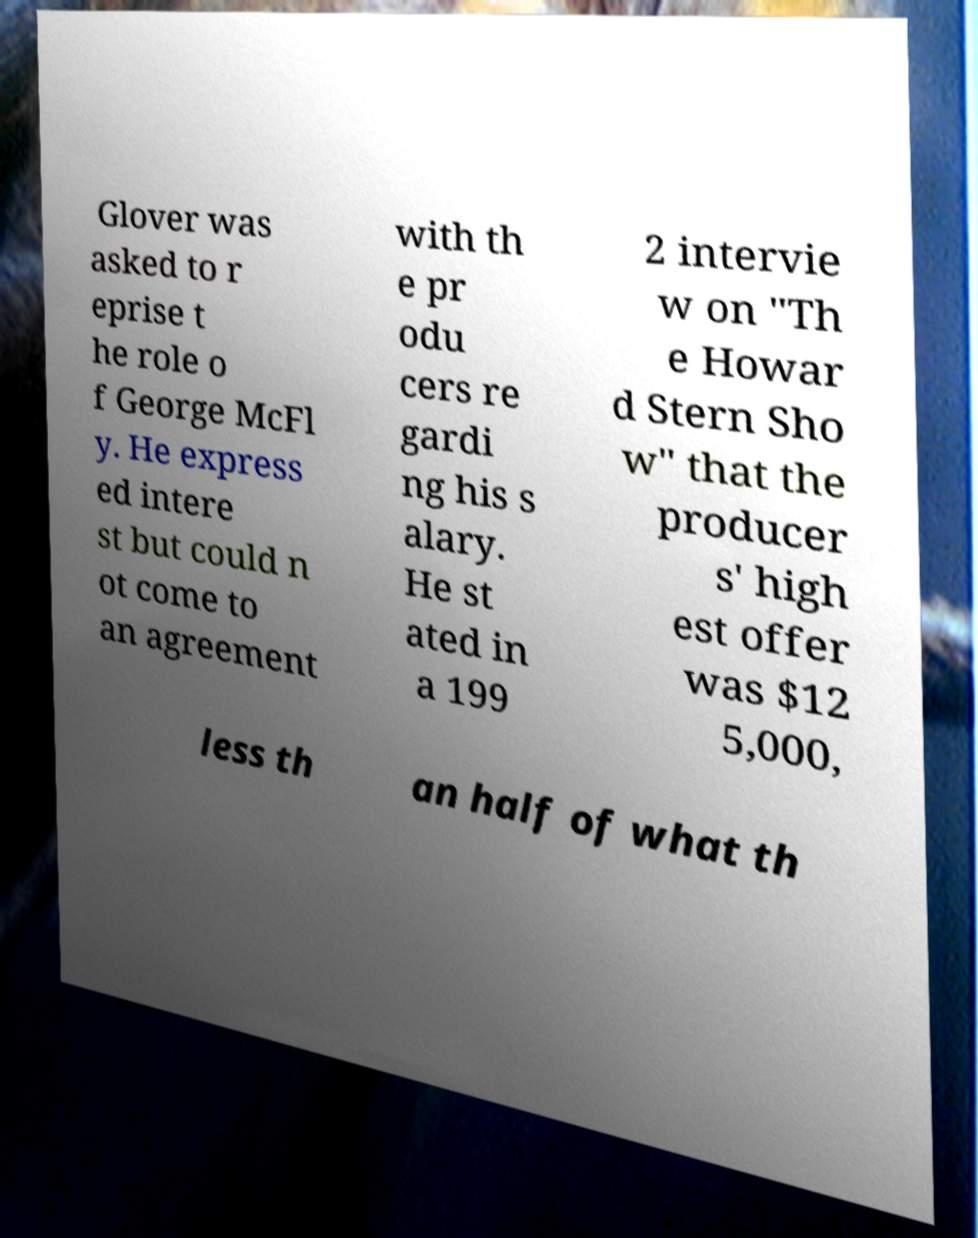I need the written content from this picture converted into text. Can you do that? Glover was asked to r eprise t he role o f George McFl y. He express ed intere st but could n ot come to an agreement with th e pr odu cers re gardi ng his s alary. He st ated in a 199 2 intervie w on "Th e Howar d Stern Sho w" that the producer s' high est offer was $12 5,000, less th an half of what th 